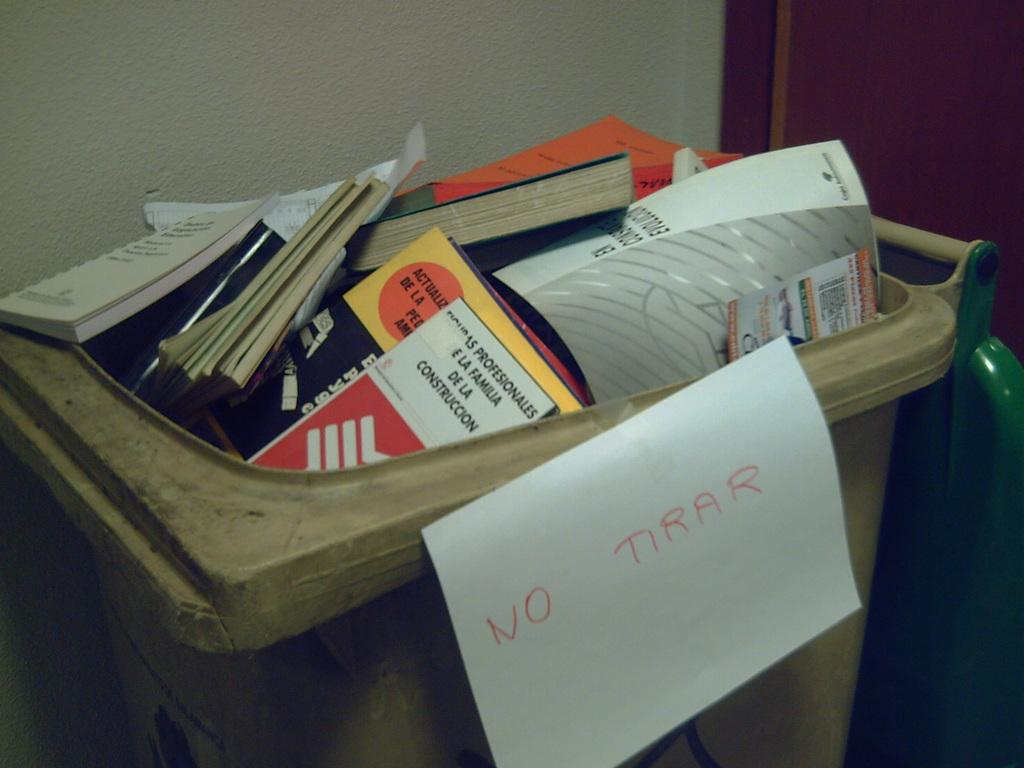<image>
Offer a succinct explanation of the picture presented. A wheely bin is full of books and note pads and has a sign on it which translated says do not throw away. 